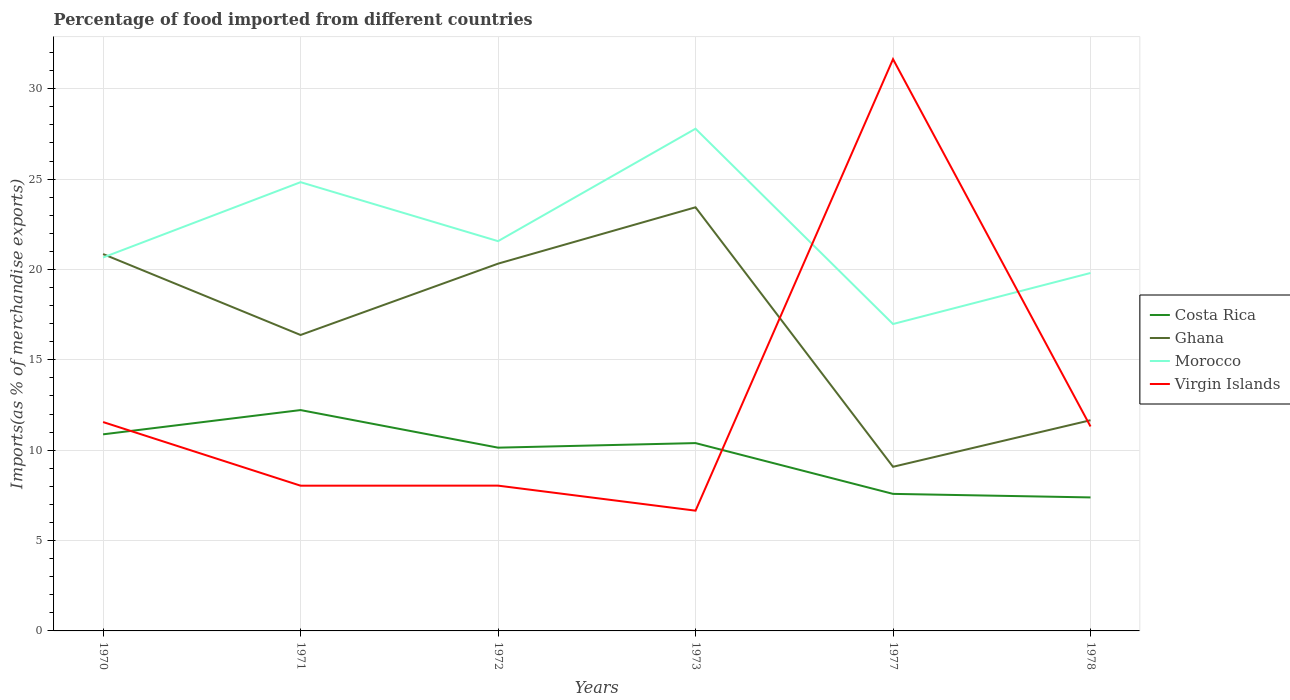Is the number of lines equal to the number of legend labels?
Offer a terse response. Yes. Across all years, what is the maximum percentage of imports to different countries in Morocco?
Offer a very short reply. 16.98. What is the total percentage of imports to different countries in Ghana in the graph?
Offer a very short reply. -3.95. What is the difference between the highest and the second highest percentage of imports to different countries in Costa Rica?
Make the answer very short. 4.83. What is the difference between the highest and the lowest percentage of imports to different countries in Virgin Islands?
Your response must be concise. 1. How many lines are there?
Provide a short and direct response. 4. How many years are there in the graph?
Provide a short and direct response. 6. Are the values on the major ticks of Y-axis written in scientific E-notation?
Give a very brief answer. No. Does the graph contain grids?
Offer a very short reply. Yes. Where does the legend appear in the graph?
Provide a succinct answer. Center right. How many legend labels are there?
Give a very brief answer. 4. How are the legend labels stacked?
Your response must be concise. Vertical. What is the title of the graph?
Keep it short and to the point. Percentage of food imported from different countries. What is the label or title of the X-axis?
Keep it short and to the point. Years. What is the label or title of the Y-axis?
Your answer should be very brief. Imports(as % of merchandise exports). What is the Imports(as % of merchandise exports) of Costa Rica in 1970?
Offer a very short reply. 10.88. What is the Imports(as % of merchandise exports) of Ghana in 1970?
Ensure brevity in your answer.  20.85. What is the Imports(as % of merchandise exports) in Morocco in 1970?
Keep it short and to the point. 20.66. What is the Imports(as % of merchandise exports) in Virgin Islands in 1970?
Offer a terse response. 11.56. What is the Imports(as % of merchandise exports) of Costa Rica in 1971?
Make the answer very short. 12.22. What is the Imports(as % of merchandise exports) of Ghana in 1971?
Your answer should be compact. 16.38. What is the Imports(as % of merchandise exports) of Morocco in 1971?
Provide a succinct answer. 24.83. What is the Imports(as % of merchandise exports) in Virgin Islands in 1971?
Provide a short and direct response. 8.04. What is the Imports(as % of merchandise exports) in Costa Rica in 1972?
Offer a very short reply. 10.14. What is the Imports(as % of merchandise exports) in Ghana in 1972?
Provide a succinct answer. 20.32. What is the Imports(as % of merchandise exports) of Morocco in 1972?
Provide a succinct answer. 21.57. What is the Imports(as % of merchandise exports) in Virgin Islands in 1972?
Keep it short and to the point. 8.04. What is the Imports(as % of merchandise exports) of Costa Rica in 1973?
Your answer should be very brief. 10.39. What is the Imports(as % of merchandise exports) in Ghana in 1973?
Ensure brevity in your answer.  23.44. What is the Imports(as % of merchandise exports) of Morocco in 1973?
Provide a succinct answer. 27.79. What is the Imports(as % of merchandise exports) in Virgin Islands in 1973?
Your answer should be compact. 6.65. What is the Imports(as % of merchandise exports) in Costa Rica in 1977?
Ensure brevity in your answer.  7.58. What is the Imports(as % of merchandise exports) in Ghana in 1977?
Provide a succinct answer. 9.08. What is the Imports(as % of merchandise exports) in Morocco in 1977?
Make the answer very short. 16.98. What is the Imports(as % of merchandise exports) in Virgin Islands in 1977?
Your answer should be very brief. 31.64. What is the Imports(as % of merchandise exports) of Costa Rica in 1978?
Provide a short and direct response. 7.39. What is the Imports(as % of merchandise exports) of Ghana in 1978?
Give a very brief answer. 11.66. What is the Imports(as % of merchandise exports) in Morocco in 1978?
Offer a very short reply. 19.81. What is the Imports(as % of merchandise exports) of Virgin Islands in 1978?
Give a very brief answer. 11.31. Across all years, what is the maximum Imports(as % of merchandise exports) of Costa Rica?
Offer a very short reply. 12.22. Across all years, what is the maximum Imports(as % of merchandise exports) in Ghana?
Offer a terse response. 23.44. Across all years, what is the maximum Imports(as % of merchandise exports) of Morocco?
Your response must be concise. 27.79. Across all years, what is the maximum Imports(as % of merchandise exports) of Virgin Islands?
Make the answer very short. 31.64. Across all years, what is the minimum Imports(as % of merchandise exports) of Costa Rica?
Provide a short and direct response. 7.39. Across all years, what is the minimum Imports(as % of merchandise exports) in Ghana?
Your response must be concise. 9.08. Across all years, what is the minimum Imports(as % of merchandise exports) of Morocco?
Your answer should be compact. 16.98. Across all years, what is the minimum Imports(as % of merchandise exports) of Virgin Islands?
Your answer should be very brief. 6.65. What is the total Imports(as % of merchandise exports) of Costa Rica in the graph?
Your answer should be very brief. 58.6. What is the total Imports(as % of merchandise exports) in Ghana in the graph?
Give a very brief answer. 101.74. What is the total Imports(as % of merchandise exports) in Morocco in the graph?
Offer a terse response. 131.64. What is the total Imports(as % of merchandise exports) of Virgin Islands in the graph?
Your answer should be compact. 77.24. What is the difference between the Imports(as % of merchandise exports) in Costa Rica in 1970 and that in 1971?
Make the answer very short. -1.34. What is the difference between the Imports(as % of merchandise exports) in Ghana in 1970 and that in 1971?
Your answer should be compact. 4.48. What is the difference between the Imports(as % of merchandise exports) of Morocco in 1970 and that in 1971?
Provide a succinct answer. -4.17. What is the difference between the Imports(as % of merchandise exports) of Virgin Islands in 1970 and that in 1971?
Ensure brevity in your answer.  3.52. What is the difference between the Imports(as % of merchandise exports) of Costa Rica in 1970 and that in 1972?
Provide a succinct answer. 0.74. What is the difference between the Imports(as % of merchandise exports) of Ghana in 1970 and that in 1972?
Give a very brief answer. 0.53. What is the difference between the Imports(as % of merchandise exports) in Morocco in 1970 and that in 1972?
Your response must be concise. -0.9. What is the difference between the Imports(as % of merchandise exports) of Virgin Islands in 1970 and that in 1972?
Provide a succinct answer. 3.52. What is the difference between the Imports(as % of merchandise exports) of Costa Rica in 1970 and that in 1973?
Your response must be concise. 0.48. What is the difference between the Imports(as % of merchandise exports) in Ghana in 1970 and that in 1973?
Provide a short and direct response. -2.59. What is the difference between the Imports(as % of merchandise exports) in Morocco in 1970 and that in 1973?
Your answer should be very brief. -7.12. What is the difference between the Imports(as % of merchandise exports) of Virgin Islands in 1970 and that in 1973?
Ensure brevity in your answer.  4.9. What is the difference between the Imports(as % of merchandise exports) of Costa Rica in 1970 and that in 1977?
Provide a succinct answer. 3.3. What is the difference between the Imports(as % of merchandise exports) in Ghana in 1970 and that in 1977?
Make the answer very short. 11.77. What is the difference between the Imports(as % of merchandise exports) of Morocco in 1970 and that in 1977?
Provide a short and direct response. 3.68. What is the difference between the Imports(as % of merchandise exports) of Virgin Islands in 1970 and that in 1977?
Provide a succinct answer. -20.08. What is the difference between the Imports(as % of merchandise exports) of Costa Rica in 1970 and that in 1978?
Offer a terse response. 3.49. What is the difference between the Imports(as % of merchandise exports) in Ghana in 1970 and that in 1978?
Your response must be concise. 9.2. What is the difference between the Imports(as % of merchandise exports) in Morocco in 1970 and that in 1978?
Your response must be concise. 0.86. What is the difference between the Imports(as % of merchandise exports) in Virgin Islands in 1970 and that in 1978?
Your answer should be compact. 0.24. What is the difference between the Imports(as % of merchandise exports) in Costa Rica in 1971 and that in 1972?
Offer a very short reply. 2.08. What is the difference between the Imports(as % of merchandise exports) of Ghana in 1971 and that in 1972?
Offer a terse response. -3.95. What is the difference between the Imports(as % of merchandise exports) in Morocco in 1971 and that in 1972?
Provide a succinct answer. 3.26. What is the difference between the Imports(as % of merchandise exports) of Virgin Islands in 1971 and that in 1972?
Your answer should be compact. -0. What is the difference between the Imports(as % of merchandise exports) of Costa Rica in 1971 and that in 1973?
Give a very brief answer. 1.83. What is the difference between the Imports(as % of merchandise exports) in Ghana in 1971 and that in 1973?
Keep it short and to the point. -7.07. What is the difference between the Imports(as % of merchandise exports) in Morocco in 1971 and that in 1973?
Your response must be concise. -2.96. What is the difference between the Imports(as % of merchandise exports) of Virgin Islands in 1971 and that in 1973?
Your answer should be very brief. 1.38. What is the difference between the Imports(as % of merchandise exports) of Costa Rica in 1971 and that in 1977?
Offer a very short reply. 4.64. What is the difference between the Imports(as % of merchandise exports) in Ghana in 1971 and that in 1977?
Give a very brief answer. 7.29. What is the difference between the Imports(as % of merchandise exports) of Morocco in 1971 and that in 1977?
Offer a terse response. 7.85. What is the difference between the Imports(as % of merchandise exports) in Virgin Islands in 1971 and that in 1977?
Make the answer very short. -23.6. What is the difference between the Imports(as % of merchandise exports) in Costa Rica in 1971 and that in 1978?
Make the answer very short. 4.83. What is the difference between the Imports(as % of merchandise exports) of Ghana in 1971 and that in 1978?
Provide a succinct answer. 4.72. What is the difference between the Imports(as % of merchandise exports) of Morocco in 1971 and that in 1978?
Keep it short and to the point. 5.02. What is the difference between the Imports(as % of merchandise exports) of Virgin Islands in 1971 and that in 1978?
Keep it short and to the point. -3.28. What is the difference between the Imports(as % of merchandise exports) of Costa Rica in 1972 and that in 1973?
Give a very brief answer. -0.25. What is the difference between the Imports(as % of merchandise exports) in Ghana in 1972 and that in 1973?
Offer a very short reply. -3.12. What is the difference between the Imports(as % of merchandise exports) in Morocco in 1972 and that in 1973?
Provide a succinct answer. -6.22. What is the difference between the Imports(as % of merchandise exports) of Virgin Islands in 1972 and that in 1973?
Your answer should be very brief. 1.39. What is the difference between the Imports(as % of merchandise exports) of Costa Rica in 1972 and that in 1977?
Give a very brief answer. 2.56. What is the difference between the Imports(as % of merchandise exports) of Ghana in 1972 and that in 1977?
Provide a succinct answer. 11.24. What is the difference between the Imports(as % of merchandise exports) in Morocco in 1972 and that in 1977?
Provide a short and direct response. 4.59. What is the difference between the Imports(as % of merchandise exports) in Virgin Islands in 1972 and that in 1977?
Make the answer very short. -23.6. What is the difference between the Imports(as % of merchandise exports) in Costa Rica in 1972 and that in 1978?
Provide a short and direct response. 2.75. What is the difference between the Imports(as % of merchandise exports) of Ghana in 1972 and that in 1978?
Your response must be concise. 8.66. What is the difference between the Imports(as % of merchandise exports) in Morocco in 1972 and that in 1978?
Provide a short and direct response. 1.76. What is the difference between the Imports(as % of merchandise exports) of Virgin Islands in 1972 and that in 1978?
Provide a succinct answer. -3.27. What is the difference between the Imports(as % of merchandise exports) of Costa Rica in 1973 and that in 1977?
Keep it short and to the point. 2.81. What is the difference between the Imports(as % of merchandise exports) in Ghana in 1973 and that in 1977?
Make the answer very short. 14.36. What is the difference between the Imports(as % of merchandise exports) of Morocco in 1973 and that in 1977?
Your answer should be very brief. 10.81. What is the difference between the Imports(as % of merchandise exports) in Virgin Islands in 1973 and that in 1977?
Offer a terse response. -24.98. What is the difference between the Imports(as % of merchandise exports) in Costa Rica in 1973 and that in 1978?
Make the answer very short. 3.01. What is the difference between the Imports(as % of merchandise exports) in Ghana in 1973 and that in 1978?
Keep it short and to the point. 11.78. What is the difference between the Imports(as % of merchandise exports) of Morocco in 1973 and that in 1978?
Give a very brief answer. 7.98. What is the difference between the Imports(as % of merchandise exports) in Virgin Islands in 1973 and that in 1978?
Your response must be concise. -4.66. What is the difference between the Imports(as % of merchandise exports) in Costa Rica in 1977 and that in 1978?
Provide a succinct answer. 0.2. What is the difference between the Imports(as % of merchandise exports) of Ghana in 1977 and that in 1978?
Give a very brief answer. -2.58. What is the difference between the Imports(as % of merchandise exports) in Morocco in 1977 and that in 1978?
Offer a terse response. -2.82. What is the difference between the Imports(as % of merchandise exports) of Virgin Islands in 1977 and that in 1978?
Your response must be concise. 20.33. What is the difference between the Imports(as % of merchandise exports) in Costa Rica in 1970 and the Imports(as % of merchandise exports) in Ghana in 1971?
Offer a terse response. -5.5. What is the difference between the Imports(as % of merchandise exports) of Costa Rica in 1970 and the Imports(as % of merchandise exports) of Morocco in 1971?
Your answer should be very brief. -13.95. What is the difference between the Imports(as % of merchandise exports) of Costa Rica in 1970 and the Imports(as % of merchandise exports) of Virgin Islands in 1971?
Your answer should be compact. 2.84. What is the difference between the Imports(as % of merchandise exports) of Ghana in 1970 and the Imports(as % of merchandise exports) of Morocco in 1971?
Offer a terse response. -3.98. What is the difference between the Imports(as % of merchandise exports) of Ghana in 1970 and the Imports(as % of merchandise exports) of Virgin Islands in 1971?
Offer a very short reply. 12.82. What is the difference between the Imports(as % of merchandise exports) of Morocco in 1970 and the Imports(as % of merchandise exports) of Virgin Islands in 1971?
Your answer should be very brief. 12.63. What is the difference between the Imports(as % of merchandise exports) in Costa Rica in 1970 and the Imports(as % of merchandise exports) in Ghana in 1972?
Your answer should be very brief. -9.44. What is the difference between the Imports(as % of merchandise exports) of Costa Rica in 1970 and the Imports(as % of merchandise exports) of Morocco in 1972?
Provide a short and direct response. -10.69. What is the difference between the Imports(as % of merchandise exports) of Costa Rica in 1970 and the Imports(as % of merchandise exports) of Virgin Islands in 1972?
Your answer should be compact. 2.84. What is the difference between the Imports(as % of merchandise exports) in Ghana in 1970 and the Imports(as % of merchandise exports) in Morocco in 1972?
Ensure brevity in your answer.  -0.71. What is the difference between the Imports(as % of merchandise exports) in Ghana in 1970 and the Imports(as % of merchandise exports) in Virgin Islands in 1972?
Ensure brevity in your answer.  12.81. What is the difference between the Imports(as % of merchandise exports) of Morocco in 1970 and the Imports(as % of merchandise exports) of Virgin Islands in 1972?
Give a very brief answer. 12.62. What is the difference between the Imports(as % of merchandise exports) in Costa Rica in 1970 and the Imports(as % of merchandise exports) in Ghana in 1973?
Ensure brevity in your answer.  -12.56. What is the difference between the Imports(as % of merchandise exports) in Costa Rica in 1970 and the Imports(as % of merchandise exports) in Morocco in 1973?
Provide a succinct answer. -16.91. What is the difference between the Imports(as % of merchandise exports) in Costa Rica in 1970 and the Imports(as % of merchandise exports) in Virgin Islands in 1973?
Offer a terse response. 4.22. What is the difference between the Imports(as % of merchandise exports) in Ghana in 1970 and the Imports(as % of merchandise exports) in Morocco in 1973?
Your answer should be compact. -6.94. What is the difference between the Imports(as % of merchandise exports) in Ghana in 1970 and the Imports(as % of merchandise exports) in Virgin Islands in 1973?
Your response must be concise. 14.2. What is the difference between the Imports(as % of merchandise exports) in Morocco in 1970 and the Imports(as % of merchandise exports) in Virgin Islands in 1973?
Your response must be concise. 14.01. What is the difference between the Imports(as % of merchandise exports) of Costa Rica in 1970 and the Imports(as % of merchandise exports) of Ghana in 1977?
Make the answer very short. 1.8. What is the difference between the Imports(as % of merchandise exports) of Costa Rica in 1970 and the Imports(as % of merchandise exports) of Morocco in 1977?
Give a very brief answer. -6.1. What is the difference between the Imports(as % of merchandise exports) of Costa Rica in 1970 and the Imports(as % of merchandise exports) of Virgin Islands in 1977?
Keep it short and to the point. -20.76. What is the difference between the Imports(as % of merchandise exports) of Ghana in 1970 and the Imports(as % of merchandise exports) of Morocco in 1977?
Offer a terse response. 3.87. What is the difference between the Imports(as % of merchandise exports) of Ghana in 1970 and the Imports(as % of merchandise exports) of Virgin Islands in 1977?
Ensure brevity in your answer.  -10.79. What is the difference between the Imports(as % of merchandise exports) in Morocco in 1970 and the Imports(as % of merchandise exports) in Virgin Islands in 1977?
Your response must be concise. -10.97. What is the difference between the Imports(as % of merchandise exports) of Costa Rica in 1970 and the Imports(as % of merchandise exports) of Ghana in 1978?
Keep it short and to the point. -0.78. What is the difference between the Imports(as % of merchandise exports) of Costa Rica in 1970 and the Imports(as % of merchandise exports) of Morocco in 1978?
Make the answer very short. -8.93. What is the difference between the Imports(as % of merchandise exports) of Costa Rica in 1970 and the Imports(as % of merchandise exports) of Virgin Islands in 1978?
Offer a very short reply. -0.44. What is the difference between the Imports(as % of merchandise exports) of Ghana in 1970 and the Imports(as % of merchandise exports) of Morocco in 1978?
Your answer should be very brief. 1.05. What is the difference between the Imports(as % of merchandise exports) of Ghana in 1970 and the Imports(as % of merchandise exports) of Virgin Islands in 1978?
Your answer should be compact. 9.54. What is the difference between the Imports(as % of merchandise exports) in Morocco in 1970 and the Imports(as % of merchandise exports) in Virgin Islands in 1978?
Provide a short and direct response. 9.35. What is the difference between the Imports(as % of merchandise exports) of Costa Rica in 1971 and the Imports(as % of merchandise exports) of Ghana in 1972?
Keep it short and to the point. -8.1. What is the difference between the Imports(as % of merchandise exports) in Costa Rica in 1971 and the Imports(as % of merchandise exports) in Morocco in 1972?
Keep it short and to the point. -9.35. What is the difference between the Imports(as % of merchandise exports) in Costa Rica in 1971 and the Imports(as % of merchandise exports) in Virgin Islands in 1972?
Ensure brevity in your answer.  4.18. What is the difference between the Imports(as % of merchandise exports) in Ghana in 1971 and the Imports(as % of merchandise exports) in Morocco in 1972?
Your answer should be very brief. -5.19. What is the difference between the Imports(as % of merchandise exports) of Ghana in 1971 and the Imports(as % of merchandise exports) of Virgin Islands in 1972?
Your response must be concise. 8.34. What is the difference between the Imports(as % of merchandise exports) of Morocco in 1971 and the Imports(as % of merchandise exports) of Virgin Islands in 1972?
Your answer should be compact. 16.79. What is the difference between the Imports(as % of merchandise exports) of Costa Rica in 1971 and the Imports(as % of merchandise exports) of Ghana in 1973?
Keep it short and to the point. -11.22. What is the difference between the Imports(as % of merchandise exports) of Costa Rica in 1971 and the Imports(as % of merchandise exports) of Morocco in 1973?
Make the answer very short. -15.57. What is the difference between the Imports(as % of merchandise exports) of Costa Rica in 1971 and the Imports(as % of merchandise exports) of Virgin Islands in 1973?
Offer a very short reply. 5.57. What is the difference between the Imports(as % of merchandise exports) of Ghana in 1971 and the Imports(as % of merchandise exports) of Morocco in 1973?
Give a very brief answer. -11.41. What is the difference between the Imports(as % of merchandise exports) of Ghana in 1971 and the Imports(as % of merchandise exports) of Virgin Islands in 1973?
Ensure brevity in your answer.  9.72. What is the difference between the Imports(as % of merchandise exports) in Morocco in 1971 and the Imports(as % of merchandise exports) in Virgin Islands in 1973?
Keep it short and to the point. 18.18. What is the difference between the Imports(as % of merchandise exports) of Costa Rica in 1971 and the Imports(as % of merchandise exports) of Ghana in 1977?
Provide a succinct answer. 3.14. What is the difference between the Imports(as % of merchandise exports) of Costa Rica in 1971 and the Imports(as % of merchandise exports) of Morocco in 1977?
Offer a very short reply. -4.76. What is the difference between the Imports(as % of merchandise exports) of Costa Rica in 1971 and the Imports(as % of merchandise exports) of Virgin Islands in 1977?
Provide a short and direct response. -19.42. What is the difference between the Imports(as % of merchandise exports) in Ghana in 1971 and the Imports(as % of merchandise exports) in Morocco in 1977?
Ensure brevity in your answer.  -0.61. What is the difference between the Imports(as % of merchandise exports) in Ghana in 1971 and the Imports(as % of merchandise exports) in Virgin Islands in 1977?
Provide a succinct answer. -15.26. What is the difference between the Imports(as % of merchandise exports) of Morocco in 1971 and the Imports(as % of merchandise exports) of Virgin Islands in 1977?
Ensure brevity in your answer.  -6.81. What is the difference between the Imports(as % of merchandise exports) of Costa Rica in 1971 and the Imports(as % of merchandise exports) of Ghana in 1978?
Offer a very short reply. 0.56. What is the difference between the Imports(as % of merchandise exports) in Costa Rica in 1971 and the Imports(as % of merchandise exports) in Morocco in 1978?
Make the answer very short. -7.59. What is the difference between the Imports(as % of merchandise exports) in Costa Rica in 1971 and the Imports(as % of merchandise exports) in Virgin Islands in 1978?
Your answer should be very brief. 0.91. What is the difference between the Imports(as % of merchandise exports) in Ghana in 1971 and the Imports(as % of merchandise exports) in Morocco in 1978?
Provide a short and direct response. -3.43. What is the difference between the Imports(as % of merchandise exports) of Ghana in 1971 and the Imports(as % of merchandise exports) of Virgin Islands in 1978?
Provide a succinct answer. 5.06. What is the difference between the Imports(as % of merchandise exports) of Morocco in 1971 and the Imports(as % of merchandise exports) of Virgin Islands in 1978?
Your answer should be very brief. 13.52. What is the difference between the Imports(as % of merchandise exports) of Costa Rica in 1972 and the Imports(as % of merchandise exports) of Ghana in 1973?
Make the answer very short. -13.3. What is the difference between the Imports(as % of merchandise exports) in Costa Rica in 1972 and the Imports(as % of merchandise exports) in Morocco in 1973?
Offer a terse response. -17.65. What is the difference between the Imports(as % of merchandise exports) of Costa Rica in 1972 and the Imports(as % of merchandise exports) of Virgin Islands in 1973?
Provide a succinct answer. 3.49. What is the difference between the Imports(as % of merchandise exports) in Ghana in 1972 and the Imports(as % of merchandise exports) in Morocco in 1973?
Your answer should be very brief. -7.47. What is the difference between the Imports(as % of merchandise exports) in Ghana in 1972 and the Imports(as % of merchandise exports) in Virgin Islands in 1973?
Ensure brevity in your answer.  13.67. What is the difference between the Imports(as % of merchandise exports) of Morocco in 1972 and the Imports(as % of merchandise exports) of Virgin Islands in 1973?
Your response must be concise. 14.91. What is the difference between the Imports(as % of merchandise exports) of Costa Rica in 1972 and the Imports(as % of merchandise exports) of Ghana in 1977?
Provide a succinct answer. 1.06. What is the difference between the Imports(as % of merchandise exports) of Costa Rica in 1972 and the Imports(as % of merchandise exports) of Morocco in 1977?
Your answer should be compact. -6.84. What is the difference between the Imports(as % of merchandise exports) in Costa Rica in 1972 and the Imports(as % of merchandise exports) in Virgin Islands in 1977?
Offer a terse response. -21.5. What is the difference between the Imports(as % of merchandise exports) in Ghana in 1972 and the Imports(as % of merchandise exports) in Morocco in 1977?
Provide a short and direct response. 3.34. What is the difference between the Imports(as % of merchandise exports) of Ghana in 1972 and the Imports(as % of merchandise exports) of Virgin Islands in 1977?
Your answer should be very brief. -11.32. What is the difference between the Imports(as % of merchandise exports) of Morocco in 1972 and the Imports(as % of merchandise exports) of Virgin Islands in 1977?
Your answer should be very brief. -10.07. What is the difference between the Imports(as % of merchandise exports) of Costa Rica in 1972 and the Imports(as % of merchandise exports) of Ghana in 1978?
Provide a short and direct response. -1.52. What is the difference between the Imports(as % of merchandise exports) in Costa Rica in 1972 and the Imports(as % of merchandise exports) in Morocco in 1978?
Provide a succinct answer. -9.67. What is the difference between the Imports(as % of merchandise exports) in Costa Rica in 1972 and the Imports(as % of merchandise exports) in Virgin Islands in 1978?
Your answer should be compact. -1.17. What is the difference between the Imports(as % of merchandise exports) of Ghana in 1972 and the Imports(as % of merchandise exports) of Morocco in 1978?
Keep it short and to the point. 0.52. What is the difference between the Imports(as % of merchandise exports) of Ghana in 1972 and the Imports(as % of merchandise exports) of Virgin Islands in 1978?
Give a very brief answer. 9.01. What is the difference between the Imports(as % of merchandise exports) of Morocco in 1972 and the Imports(as % of merchandise exports) of Virgin Islands in 1978?
Provide a succinct answer. 10.25. What is the difference between the Imports(as % of merchandise exports) in Costa Rica in 1973 and the Imports(as % of merchandise exports) in Ghana in 1977?
Give a very brief answer. 1.31. What is the difference between the Imports(as % of merchandise exports) of Costa Rica in 1973 and the Imports(as % of merchandise exports) of Morocco in 1977?
Your response must be concise. -6.59. What is the difference between the Imports(as % of merchandise exports) of Costa Rica in 1973 and the Imports(as % of merchandise exports) of Virgin Islands in 1977?
Offer a very short reply. -21.25. What is the difference between the Imports(as % of merchandise exports) in Ghana in 1973 and the Imports(as % of merchandise exports) in Morocco in 1977?
Provide a succinct answer. 6.46. What is the difference between the Imports(as % of merchandise exports) of Ghana in 1973 and the Imports(as % of merchandise exports) of Virgin Islands in 1977?
Ensure brevity in your answer.  -8.2. What is the difference between the Imports(as % of merchandise exports) in Morocco in 1973 and the Imports(as % of merchandise exports) in Virgin Islands in 1977?
Give a very brief answer. -3.85. What is the difference between the Imports(as % of merchandise exports) in Costa Rica in 1973 and the Imports(as % of merchandise exports) in Ghana in 1978?
Ensure brevity in your answer.  -1.26. What is the difference between the Imports(as % of merchandise exports) of Costa Rica in 1973 and the Imports(as % of merchandise exports) of Morocco in 1978?
Your answer should be compact. -9.41. What is the difference between the Imports(as % of merchandise exports) of Costa Rica in 1973 and the Imports(as % of merchandise exports) of Virgin Islands in 1978?
Ensure brevity in your answer.  -0.92. What is the difference between the Imports(as % of merchandise exports) of Ghana in 1973 and the Imports(as % of merchandise exports) of Morocco in 1978?
Provide a succinct answer. 3.63. What is the difference between the Imports(as % of merchandise exports) in Ghana in 1973 and the Imports(as % of merchandise exports) in Virgin Islands in 1978?
Ensure brevity in your answer.  12.13. What is the difference between the Imports(as % of merchandise exports) in Morocco in 1973 and the Imports(as % of merchandise exports) in Virgin Islands in 1978?
Your answer should be very brief. 16.48. What is the difference between the Imports(as % of merchandise exports) of Costa Rica in 1977 and the Imports(as % of merchandise exports) of Ghana in 1978?
Make the answer very short. -4.08. What is the difference between the Imports(as % of merchandise exports) of Costa Rica in 1977 and the Imports(as % of merchandise exports) of Morocco in 1978?
Offer a very short reply. -12.22. What is the difference between the Imports(as % of merchandise exports) of Costa Rica in 1977 and the Imports(as % of merchandise exports) of Virgin Islands in 1978?
Your response must be concise. -3.73. What is the difference between the Imports(as % of merchandise exports) of Ghana in 1977 and the Imports(as % of merchandise exports) of Morocco in 1978?
Keep it short and to the point. -10.72. What is the difference between the Imports(as % of merchandise exports) in Ghana in 1977 and the Imports(as % of merchandise exports) in Virgin Islands in 1978?
Offer a terse response. -2.23. What is the difference between the Imports(as % of merchandise exports) of Morocco in 1977 and the Imports(as % of merchandise exports) of Virgin Islands in 1978?
Keep it short and to the point. 5.67. What is the average Imports(as % of merchandise exports) of Costa Rica per year?
Your answer should be very brief. 9.77. What is the average Imports(as % of merchandise exports) in Ghana per year?
Make the answer very short. 16.96. What is the average Imports(as % of merchandise exports) in Morocco per year?
Offer a very short reply. 21.94. What is the average Imports(as % of merchandise exports) of Virgin Islands per year?
Provide a short and direct response. 12.87. In the year 1970, what is the difference between the Imports(as % of merchandise exports) in Costa Rica and Imports(as % of merchandise exports) in Ghana?
Offer a very short reply. -9.98. In the year 1970, what is the difference between the Imports(as % of merchandise exports) of Costa Rica and Imports(as % of merchandise exports) of Morocco?
Provide a succinct answer. -9.79. In the year 1970, what is the difference between the Imports(as % of merchandise exports) in Costa Rica and Imports(as % of merchandise exports) in Virgin Islands?
Ensure brevity in your answer.  -0.68. In the year 1970, what is the difference between the Imports(as % of merchandise exports) of Ghana and Imports(as % of merchandise exports) of Morocco?
Your answer should be compact. 0.19. In the year 1970, what is the difference between the Imports(as % of merchandise exports) in Ghana and Imports(as % of merchandise exports) in Virgin Islands?
Offer a terse response. 9.3. In the year 1970, what is the difference between the Imports(as % of merchandise exports) in Morocco and Imports(as % of merchandise exports) in Virgin Islands?
Keep it short and to the point. 9.11. In the year 1971, what is the difference between the Imports(as % of merchandise exports) in Costa Rica and Imports(as % of merchandise exports) in Ghana?
Make the answer very short. -4.16. In the year 1971, what is the difference between the Imports(as % of merchandise exports) of Costa Rica and Imports(as % of merchandise exports) of Morocco?
Provide a succinct answer. -12.61. In the year 1971, what is the difference between the Imports(as % of merchandise exports) in Costa Rica and Imports(as % of merchandise exports) in Virgin Islands?
Ensure brevity in your answer.  4.18. In the year 1971, what is the difference between the Imports(as % of merchandise exports) of Ghana and Imports(as % of merchandise exports) of Morocco?
Offer a terse response. -8.46. In the year 1971, what is the difference between the Imports(as % of merchandise exports) in Ghana and Imports(as % of merchandise exports) in Virgin Islands?
Ensure brevity in your answer.  8.34. In the year 1971, what is the difference between the Imports(as % of merchandise exports) of Morocco and Imports(as % of merchandise exports) of Virgin Islands?
Your answer should be very brief. 16.8. In the year 1972, what is the difference between the Imports(as % of merchandise exports) in Costa Rica and Imports(as % of merchandise exports) in Ghana?
Your answer should be compact. -10.18. In the year 1972, what is the difference between the Imports(as % of merchandise exports) of Costa Rica and Imports(as % of merchandise exports) of Morocco?
Give a very brief answer. -11.43. In the year 1972, what is the difference between the Imports(as % of merchandise exports) in Costa Rica and Imports(as % of merchandise exports) in Virgin Islands?
Your answer should be very brief. 2.1. In the year 1972, what is the difference between the Imports(as % of merchandise exports) of Ghana and Imports(as % of merchandise exports) of Morocco?
Provide a succinct answer. -1.25. In the year 1972, what is the difference between the Imports(as % of merchandise exports) in Ghana and Imports(as % of merchandise exports) in Virgin Islands?
Offer a very short reply. 12.28. In the year 1972, what is the difference between the Imports(as % of merchandise exports) of Morocco and Imports(as % of merchandise exports) of Virgin Islands?
Provide a short and direct response. 13.53. In the year 1973, what is the difference between the Imports(as % of merchandise exports) in Costa Rica and Imports(as % of merchandise exports) in Ghana?
Ensure brevity in your answer.  -13.05. In the year 1973, what is the difference between the Imports(as % of merchandise exports) in Costa Rica and Imports(as % of merchandise exports) in Morocco?
Provide a succinct answer. -17.4. In the year 1973, what is the difference between the Imports(as % of merchandise exports) in Costa Rica and Imports(as % of merchandise exports) in Virgin Islands?
Offer a terse response. 3.74. In the year 1973, what is the difference between the Imports(as % of merchandise exports) in Ghana and Imports(as % of merchandise exports) in Morocco?
Provide a short and direct response. -4.35. In the year 1973, what is the difference between the Imports(as % of merchandise exports) of Ghana and Imports(as % of merchandise exports) of Virgin Islands?
Make the answer very short. 16.79. In the year 1973, what is the difference between the Imports(as % of merchandise exports) in Morocco and Imports(as % of merchandise exports) in Virgin Islands?
Provide a short and direct response. 21.14. In the year 1977, what is the difference between the Imports(as % of merchandise exports) in Costa Rica and Imports(as % of merchandise exports) in Ghana?
Ensure brevity in your answer.  -1.5. In the year 1977, what is the difference between the Imports(as % of merchandise exports) in Costa Rica and Imports(as % of merchandise exports) in Morocco?
Keep it short and to the point. -9.4. In the year 1977, what is the difference between the Imports(as % of merchandise exports) in Costa Rica and Imports(as % of merchandise exports) in Virgin Islands?
Your answer should be compact. -24.06. In the year 1977, what is the difference between the Imports(as % of merchandise exports) of Ghana and Imports(as % of merchandise exports) of Morocco?
Give a very brief answer. -7.9. In the year 1977, what is the difference between the Imports(as % of merchandise exports) in Ghana and Imports(as % of merchandise exports) in Virgin Islands?
Make the answer very short. -22.56. In the year 1977, what is the difference between the Imports(as % of merchandise exports) in Morocco and Imports(as % of merchandise exports) in Virgin Islands?
Give a very brief answer. -14.66. In the year 1978, what is the difference between the Imports(as % of merchandise exports) of Costa Rica and Imports(as % of merchandise exports) of Ghana?
Offer a very short reply. -4.27. In the year 1978, what is the difference between the Imports(as % of merchandise exports) of Costa Rica and Imports(as % of merchandise exports) of Morocco?
Offer a very short reply. -12.42. In the year 1978, what is the difference between the Imports(as % of merchandise exports) of Costa Rica and Imports(as % of merchandise exports) of Virgin Islands?
Give a very brief answer. -3.93. In the year 1978, what is the difference between the Imports(as % of merchandise exports) of Ghana and Imports(as % of merchandise exports) of Morocco?
Keep it short and to the point. -8.15. In the year 1978, what is the difference between the Imports(as % of merchandise exports) of Ghana and Imports(as % of merchandise exports) of Virgin Islands?
Make the answer very short. 0.35. In the year 1978, what is the difference between the Imports(as % of merchandise exports) in Morocco and Imports(as % of merchandise exports) in Virgin Islands?
Your response must be concise. 8.49. What is the ratio of the Imports(as % of merchandise exports) of Costa Rica in 1970 to that in 1971?
Your response must be concise. 0.89. What is the ratio of the Imports(as % of merchandise exports) in Ghana in 1970 to that in 1971?
Make the answer very short. 1.27. What is the ratio of the Imports(as % of merchandise exports) in Morocco in 1970 to that in 1971?
Give a very brief answer. 0.83. What is the ratio of the Imports(as % of merchandise exports) of Virgin Islands in 1970 to that in 1971?
Your response must be concise. 1.44. What is the ratio of the Imports(as % of merchandise exports) of Costa Rica in 1970 to that in 1972?
Offer a very short reply. 1.07. What is the ratio of the Imports(as % of merchandise exports) in Ghana in 1970 to that in 1972?
Provide a succinct answer. 1.03. What is the ratio of the Imports(as % of merchandise exports) of Morocco in 1970 to that in 1972?
Offer a very short reply. 0.96. What is the ratio of the Imports(as % of merchandise exports) of Virgin Islands in 1970 to that in 1972?
Your answer should be compact. 1.44. What is the ratio of the Imports(as % of merchandise exports) in Costa Rica in 1970 to that in 1973?
Offer a very short reply. 1.05. What is the ratio of the Imports(as % of merchandise exports) of Ghana in 1970 to that in 1973?
Offer a very short reply. 0.89. What is the ratio of the Imports(as % of merchandise exports) of Morocco in 1970 to that in 1973?
Ensure brevity in your answer.  0.74. What is the ratio of the Imports(as % of merchandise exports) in Virgin Islands in 1970 to that in 1973?
Your response must be concise. 1.74. What is the ratio of the Imports(as % of merchandise exports) of Costa Rica in 1970 to that in 1977?
Ensure brevity in your answer.  1.43. What is the ratio of the Imports(as % of merchandise exports) of Ghana in 1970 to that in 1977?
Provide a short and direct response. 2.3. What is the ratio of the Imports(as % of merchandise exports) in Morocco in 1970 to that in 1977?
Offer a very short reply. 1.22. What is the ratio of the Imports(as % of merchandise exports) of Virgin Islands in 1970 to that in 1977?
Offer a terse response. 0.37. What is the ratio of the Imports(as % of merchandise exports) of Costa Rica in 1970 to that in 1978?
Give a very brief answer. 1.47. What is the ratio of the Imports(as % of merchandise exports) of Ghana in 1970 to that in 1978?
Provide a succinct answer. 1.79. What is the ratio of the Imports(as % of merchandise exports) of Morocco in 1970 to that in 1978?
Your answer should be very brief. 1.04. What is the ratio of the Imports(as % of merchandise exports) in Virgin Islands in 1970 to that in 1978?
Your answer should be compact. 1.02. What is the ratio of the Imports(as % of merchandise exports) in Costa Rica in 1971 to that in 1972?
Make the answer very short. 1.21. What is the ratio of the Imports(as % of merchandise exports) in Ghana in 1971 to that in 1972?
Ensure brevity in your answer.  0.81. What is the ratio of the Imports(as % of merchandise exports) in Morocco in 1971 to that in 1972?
Offer a terse response. 1.15. What is the ratio of the Imports(as % of merchandise exports) of Virgin Islands in 1971 to that in 1972?
Ensure brevity in your answer.  1. What is the ratio of the Imports(as % of merchandise exports) in Costa Rica in 1971 to that in 1973?
Make the answer very short. 1.18. What is the ratio of the Imports(as % of merchandise exports) in Ghana in 1971 to that in 1973?
Ensure brevity in your answer.  0.7. What is the ratio of the Imports(as % of merchandise exports) in Morocco in 1971 to that in 1973?
Make the answer very short. 0.89. What is the ratio of the Imports(as % of merchandise exports) in Virgin Islands in 1971 to that in 1973?
Offer a terse response. 1.21. What is the ratio of the Imports(as % of merchandise exports) of Costa Rica in 1971 to that in 1977?
Your answer should be very brief. 1.61. What is the ratio of the Imports(as % of merchandise exports) in Ghana in 1971 to that in 1977?
Provide a short and direct response. 1.8. What is the ratio of the Imports(as % of merchandise exports) of Morocco in 1971 to that in 1977?
Offer a very short reply. 1.46. What is the ratio of the Imports(as % of merchandise exports) of Virgin Islands in 1971 to that in 1977?
Offer a terse response. 0.25. What is the ratio of the Imports(as % of merchandise exports) of Costa Rica in 1971 to that in 1978?
Ensure brevity in your answer.  1.65. What is the ratio of the Imports(as % of merchandise exports) of Ghana in 1971 to that in 1978?
Ensure brevity in your answer.  1.4. What is the ratio of the Imports(as % of merchandise exports) in Morocco in 1971 to that in 1978?
Ensure brevity in your answer.  1.25. What is the ratio of the Imports(as % of merchandise exports) in Virgin Islands in 1971 to that in 1978?
Provide a succinct answer. 0.71. What is the ratio of the Imports(as % of merchandise exports) of Costa Rica in 1972 to that in 1973?
Give a very brief answer. 0.98. What is the ratio of the Imports(as % of merchandise exports) of Ghana in 1972 to that in 1973?
Your answer should be very brief. 0.87. What is the ratio of the Imports(as % of merchandise exports) of Morocco in 1972 to that in 1973?
Provide a succinct answer. 0.78. What is the ratio of the Imports(as % of merchandise exports) in Virgin Islands in 1972 to that in 1973?
Offer a terse response. 1.21. What is the ratio of the Imports(as % of merchandise exports) in Costa Rica in 1972 to that in 1977?
Offer a terse response. 1.34. What is the ratio of the Imports(as % of merchandise exports) in Ghana in 1972 to that in 1977?
Your answer should be compact. 2.24. What is the ratio of the Imports(as % of merchandise exports) of Morocco in 1972 to that in 1977?
Make the answer very short. 1.27. What is the ratio of the Imports(as % of merchandise exports) in Virgin Islands in 1972 to that in 1977?
Give a very brief answer. 0.25. What is the ratio of the Imports(as % of merchandise exports) of Costa Rica in 1972 to that in 1978?
Your response must be concise. 1.37. What is the ratio of the Imports(as % of merchandise exports) in Ghana in 1972 to that in 1978?
Provide a short and direct response. 1.74. What is the ratio of the Imports(as % of merchandise exports) in Morocco in 1972 to that in 1978?
Offer a very short reply. 1.09. What is the ratio of the Imports(as % of merchandise exports) of Virgin Islands in 1972 to that in 1978?
Your answer should be compact. 0.71. What is the ratio of the Imports(as % of merchandise exports) in Costa Rica in 1973 to that in 1977?
Your answer should be very brief. 1.37. What is the ratio of the Imports(as % of merchandise exports) in Ghana in 1973 to that in 1977?
Your response must be concise. 2.58. What is the ratio of the Imports(as % of merchandise exports) in Morocco in 1973 to that in 1977?
Offer a terse response. 1.64. What is the ratio of the Imports(as % of merchandise exports) in Virgin Islands in 1973 to that in 1977?
Give a very brief answer. 0.21. What is the ratio of the Imports(as % of merchandise exports) in Costa Rica in 1973 to that in 1978?
Offer a very short reply. 1.41. What is the ratio of the Imports(as % of merchandise exports) of Ghana in 1973 to that in 1978?
Give a very brief answer. 2.01. What is the ratio of the Imports(as % of merchandise exports) of Morocco in 1973 to that in 1978?
Make the answer very short. 1.4. What is the ratio of the Imports(as % of merchandise exports) in Virgin Islands in 1973 to that in 1978?
Provide a succinct answer. 0.59. What is the ratio of the Imports(as % of merchandise exports) of Costa Rica in 1977 to that in 1978?
Offer a terse response. 1.03. What is the ratio of the Imports(as % of merchandise exports) of Ghana in 1977 to that in 1978?
Make the answer very short. 0.78. What is the ratio of the Imports(as % of merchandise exports) in Morocco in 1977 to that in 1978?
Your answer should be very brief. 0.86. What is the ratio of the Imports(as % of merchandise exports) of Virgin Islands in 1977 to that in 1978?
Offer a terse response. 2.8. What is the difference between the highest and the second highest Imports(as % of merchandise exports) of Costa Rica?
Give a very brief answer. 1.34. What is the difference between the highest and the second highest Imports(as % of merchandise exports) in Ghana?
Provide a succinct answer. 2.59. What is the difference between the highest and the second highest Imports(as % of merchandise exports) of Morocco?
Give a very brief answer. 2.96. What is the difference between the highest and the second highest Imports(as % of merchandise exports) of Virgin Islands?
Your answer should be very brief. 20.08. What is the difference between the highest and the lowest Imports(as % of merchandise exports) in Costa Rica?
Keep it short and to the point. 4.83. What is the difference between the highest and the lowest Imports(as % of merchandise exports) in Ghana?
Make the answer very short. 14.36. What is the difference between the highest and the lowest Imports(as % of merchandise exports) in Morocco?
Provide a succinct answer. 10.81. What is the difference between the highest and the lowest Imports(as % of merchandise exports) of Virgin Islands?
Offer a terse response. 24.98. 